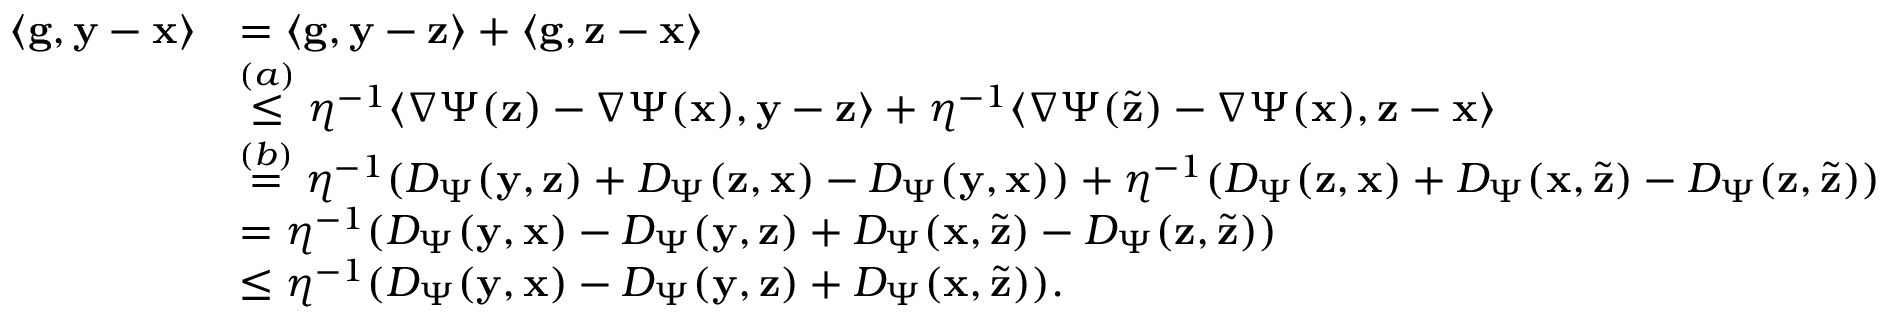Convert formula to latex. <formula><loc_0><loc_0><loc_500><loc_500>\begin{array} { r l } { \langle \mathbf g , \mathbf y - \mathbf x \rangle } & { = \langle \mathbf g , \mathbf y - \mathbf z \rangle + \langle \mathbf g , \mathbf z - \mathbf x \rangle } \\ & { \stackrel { ( a ) } \leq \eta ^ { - 1 } \langle \nabla \Psi ( \mathbf z ) - \nabla \Psi ( \mathbf x ) , \mathbf y - \mathbf z \rangle + \eta ^ { - 1 } \langle \nabla \Psi ( \widetilde { \mathbf z } ) - \nabla \Psi ( \mathbf x ) , \mathbf z - \mathbf x \rangle } \\ & { \stackrel { ( b ) } = \eta ^ { - 1 } ( D _ { \Psi } ( \mathbf y , \mathbf z ) + D _ { \Psi } ( \mathbf z , \mathbf x ) - D _ { \Psi } ( \mathbf y , \mathbf x ) ) + \eta ^ { - 1 } ( D _ { \Psi } ( \mathbf z , \mathbf x ) + D _ { \Psi } ( \mathbf x , \widetilde { \mathbf z } ) - D _ { \Psi } ( \mathbf z , \widetilde { \mathbf z } ) ) } \\ & { = \eta ^ { - 1 } ( D _ { \Psi } ( \mathbf y , \mathbf x ) - D _ { \Psi } ( \mathbf y , \mathbf z ) + D _ { \Psi } ( \mathbf x , \widetilde { \mathbf z } ) - D _ { \Psi } ( \mathbf z , \widetilde { \mathbf z } ) ) } \\ & { \leq \eta ^ { - 1 } ( D _ { \Psi } ( \mathbf y , \mathbf x ) - D _ { \Psi } ( \mathbf y , \mathbf z ) + D _ { \Psi } ( \mathbf x , \widetilde { \mathbf z } ) ) . } \end{array}</formula> 